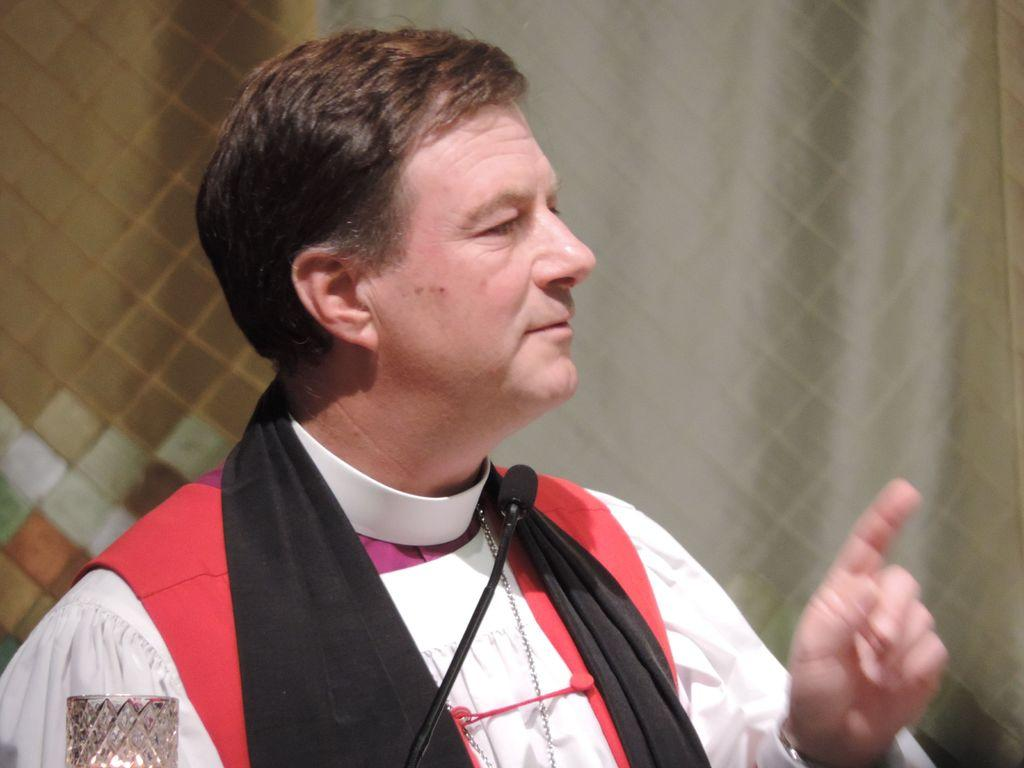Who is present in the image? There is a man in the image. What is the man doing in the image? The man is looking and pointing towards the right side of the image. What object is in front of the man? There is a mic in front of the man. What color is the tail of the animal in the image? There is no animal with a tail present in the image. How many cushions are visible in the image? There is no mention of cushions in the provided facts, so we cannot determine their presence or quantity in the image. 